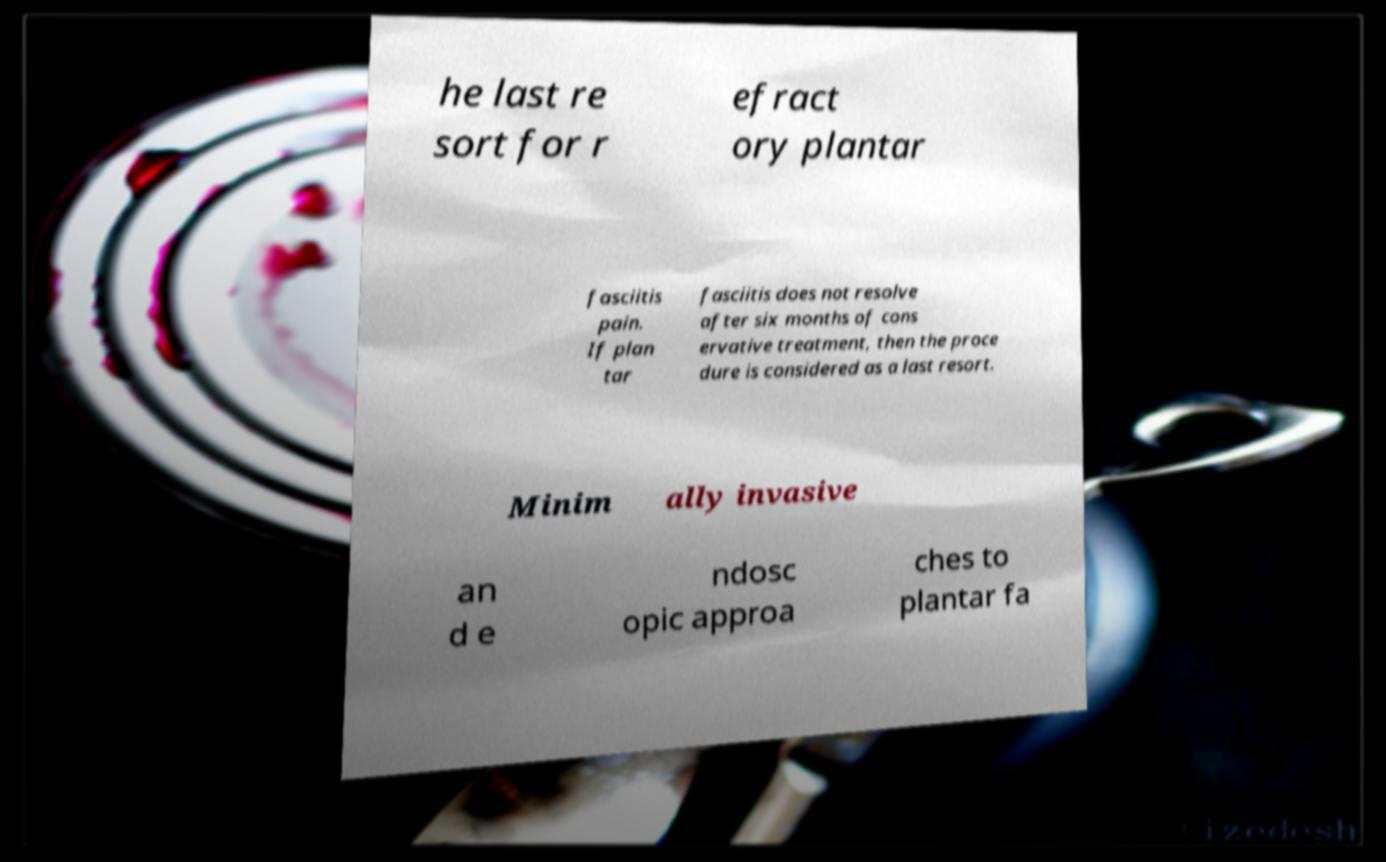Can you read and provide the text displayed in the image?This photo seems to have some interesting text. Can you extract and type it out for me? he last re sort for r efract ory plantar fasciitis pain. If plan tar fasciitis does not resolve after six months of cons ervative treatment, then the proce dure is considered as a last resort. Minim ally invasive an d e ndosc opic approa ches to plantar fa 